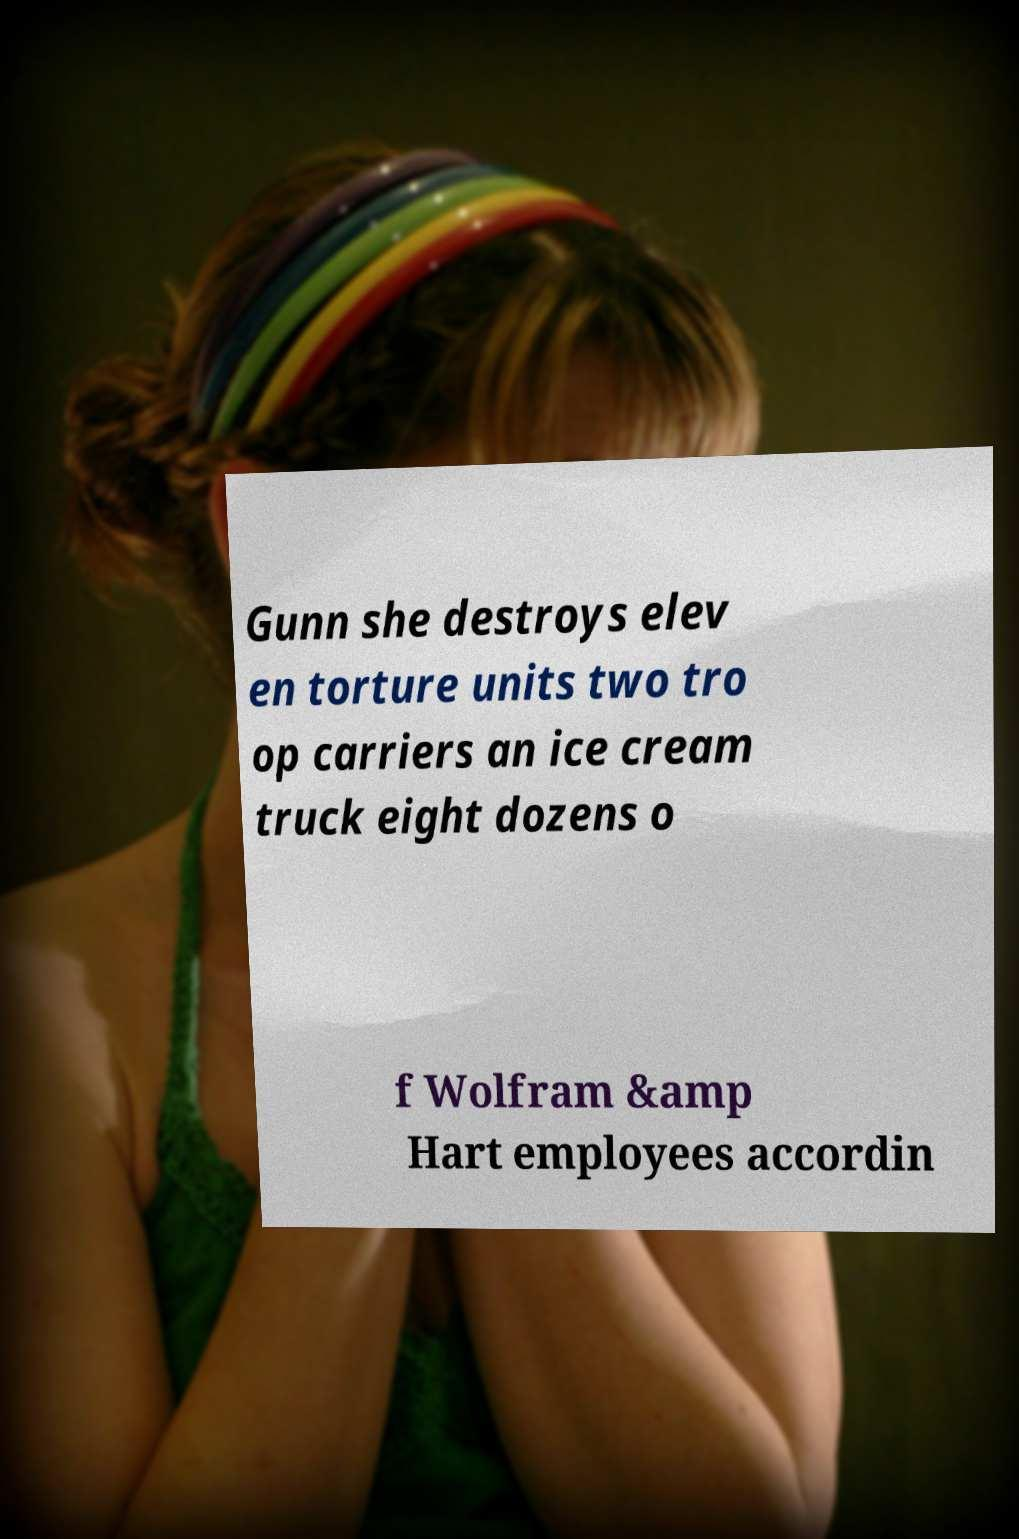Can you read and provide the text displayed in the image?This photo seems to have some interesting text. Can you extract and type it out for me? Gunn she destroys elev en torture units two tro op carriers an ice cream truck eight dozens o f Wolfram &amp Hart employees accordin 